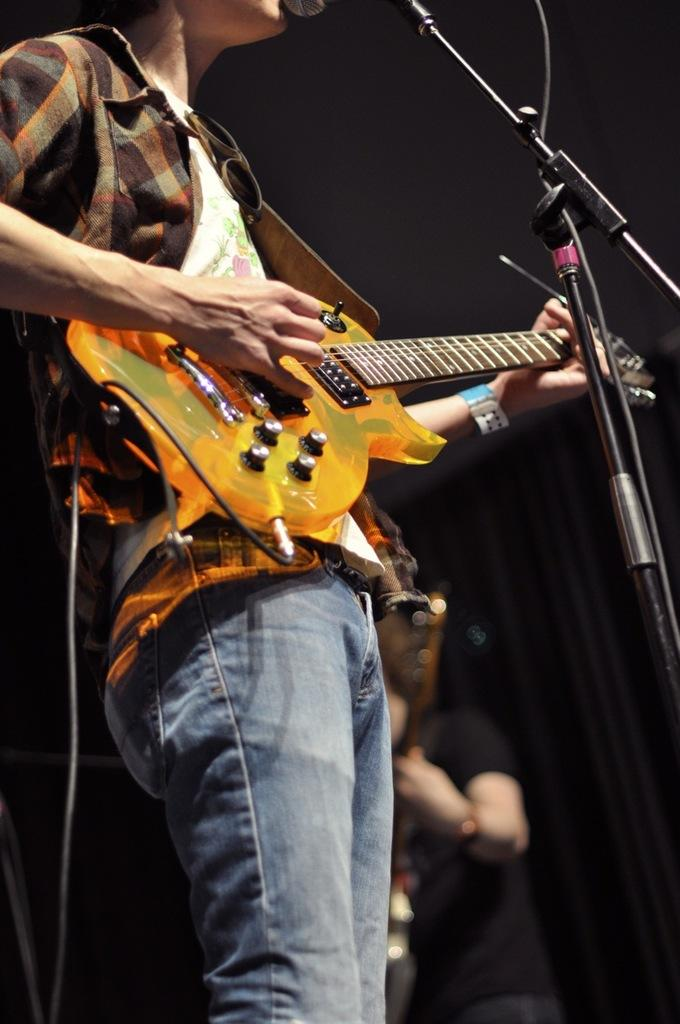What is the man in the image doing? The man is playing the guitar. What type of clothing is the man wearing on his upper body? The man is wearing a shirt. What type of clothing is the man wearing on his lower body? The man is wearing jeans. What type of popcorn is the man eating while playing the guitar? There is no popcorn present in the image, and the man is not eating anything. 